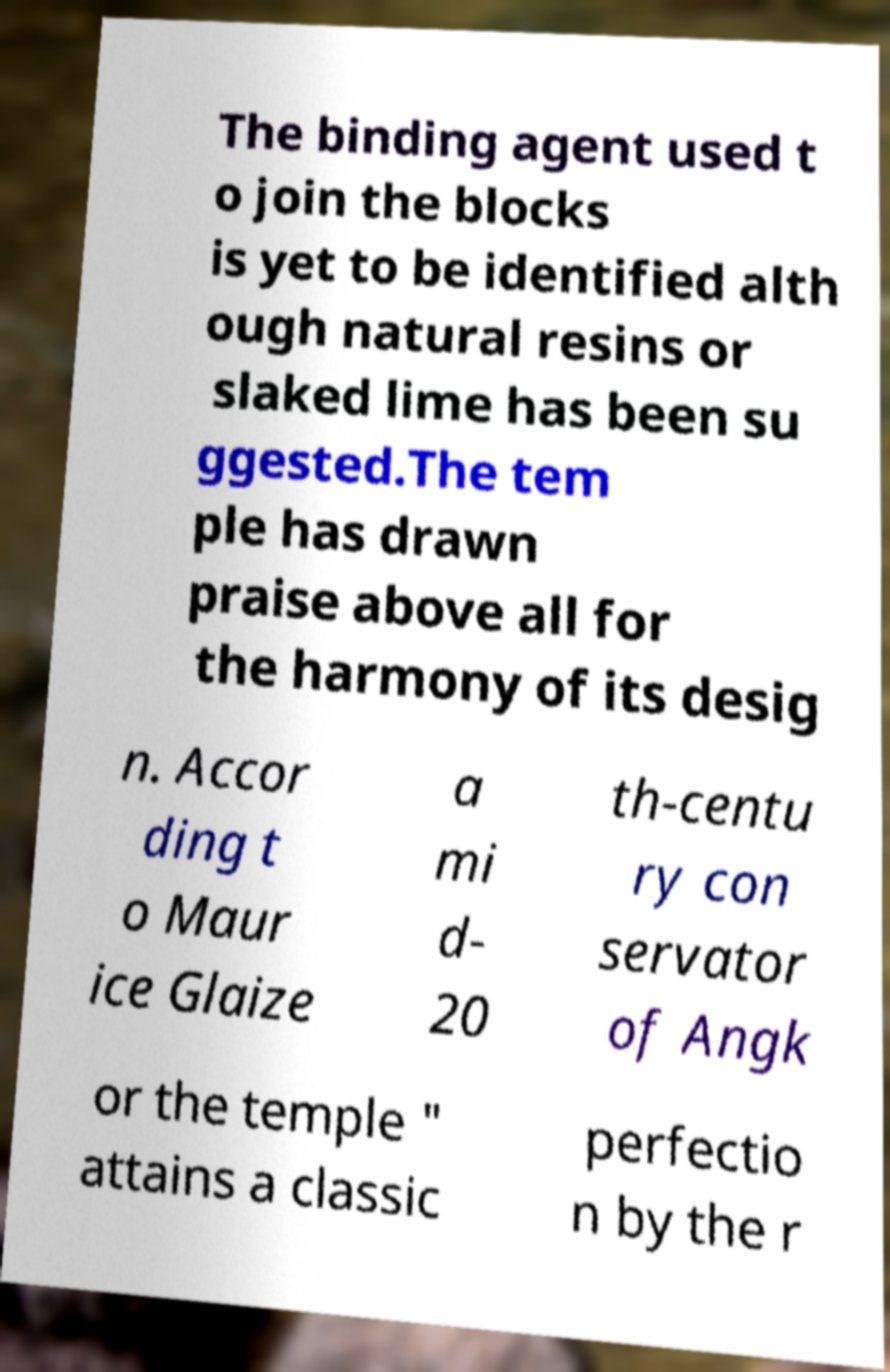What messages or text are displayed in this image? I need them in a readable, typed format. The binding agent used t o join the blocks is yet to be identified alth ough natural resins or slaked lime has been su ggested.The tem ple has drawn praise above all for the harmony of its desig n. Accor ding t o Maur ice Glaize a mi d- 20 th-centu ry con servator of Angk or the temple " attains a classic perfectio n by the r 